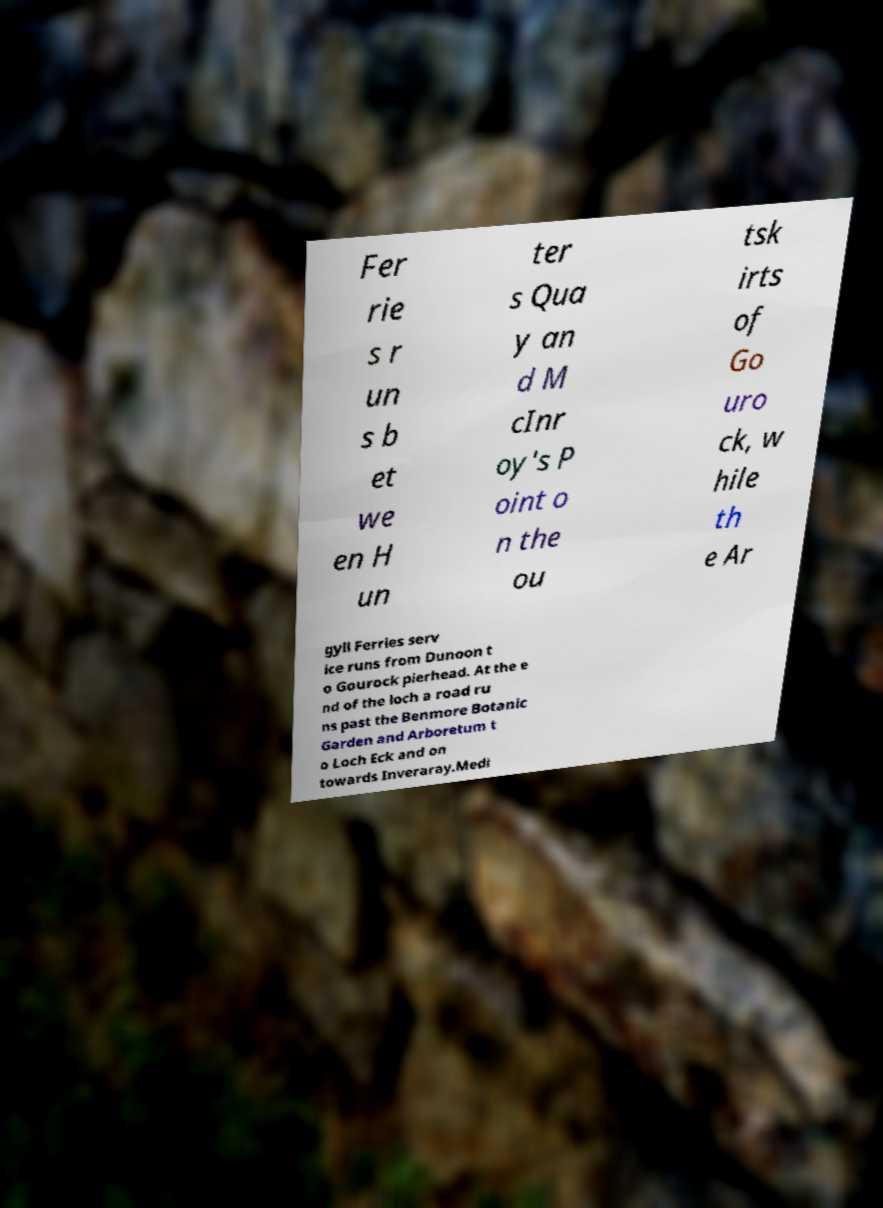Could you extract and type out the text from this image? Fer rie s r un s b et we en H un ter s Qua y an d M cInr oy's P oint o n the ou tsk irts of Go uro ck, w hile th e Ar gyll Ferries serv ice runs from Dunoon t o Gourock pierhead. At the e nd of the loch a road ru ns past the Benmore Botanic Garden and Arboretum t o Loch Eck and on towards Inveraray.Medi 